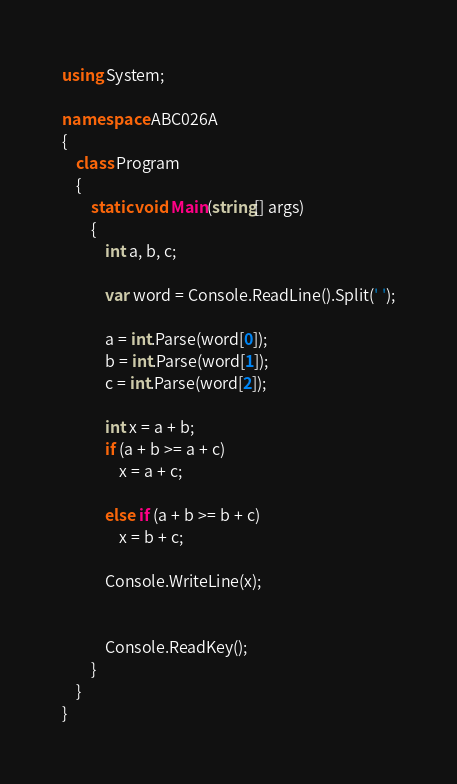Convert code to text. <code><loc_0><loc_0><loc_500><loc_500><_C#_>using System;

namespace ABC026A
{
    class Program
    {
        static void Main(string[] args)
        {
            int a, b, c;

            var word = Console.ReadLine().Split(' ');

            a = int.Parse(word[0]);
            b = int.Parse(word[1]);
            c = int.Parse(word[2]);

            int x = a + b;
            if (a + b >= a + c)
                x = a + c;

            else if (a + b >= b + c)
                x = b + c;

            Console.WriteLine(x);


            Console.ReadKey();
        }
    }
}
</code> 